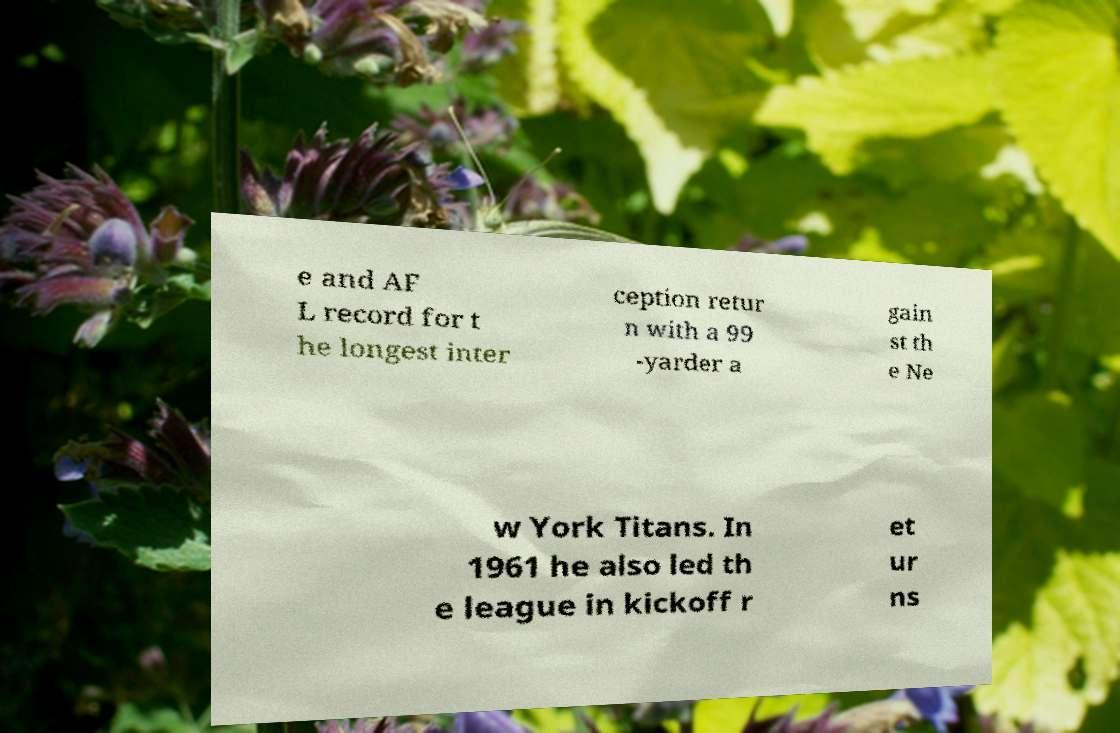What messages or text are displayed in this image? I need them in a readable, typed format. e and AF L record for t he longest inter ception retur n with a 99 -yarder a gain st th e Ne w York Titans. In 1961 he also led th e league in kickoff r et ur ns 